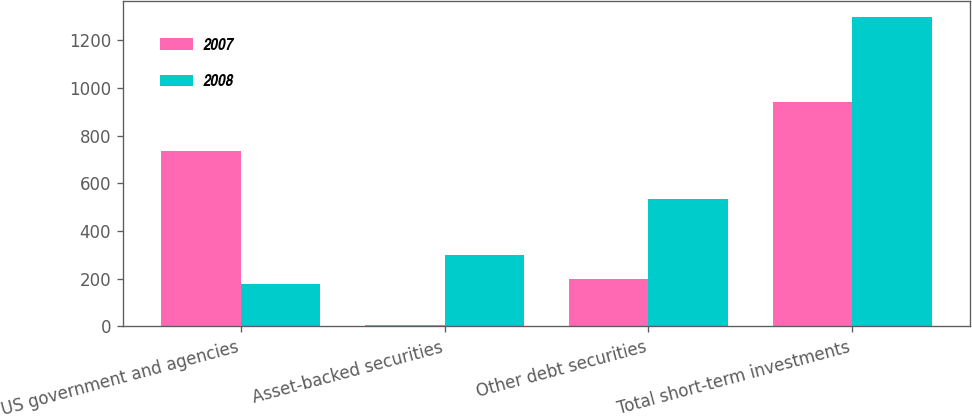<chart> <loc_0><loc_0><loc_500><loc_500><stacked_bar_chart><ecel><fcel>US government and agencies<fcel>Asset-backed securities<fcel>Other debt securities<fcel>Total short-term investments<nl><fcel>2007<fcel>737<fcel>5<fcel>201<fcel>943<nl><fcel>2008<fcel>179<fcel>301<fcel>535<fcel>1300<nl></chart> 